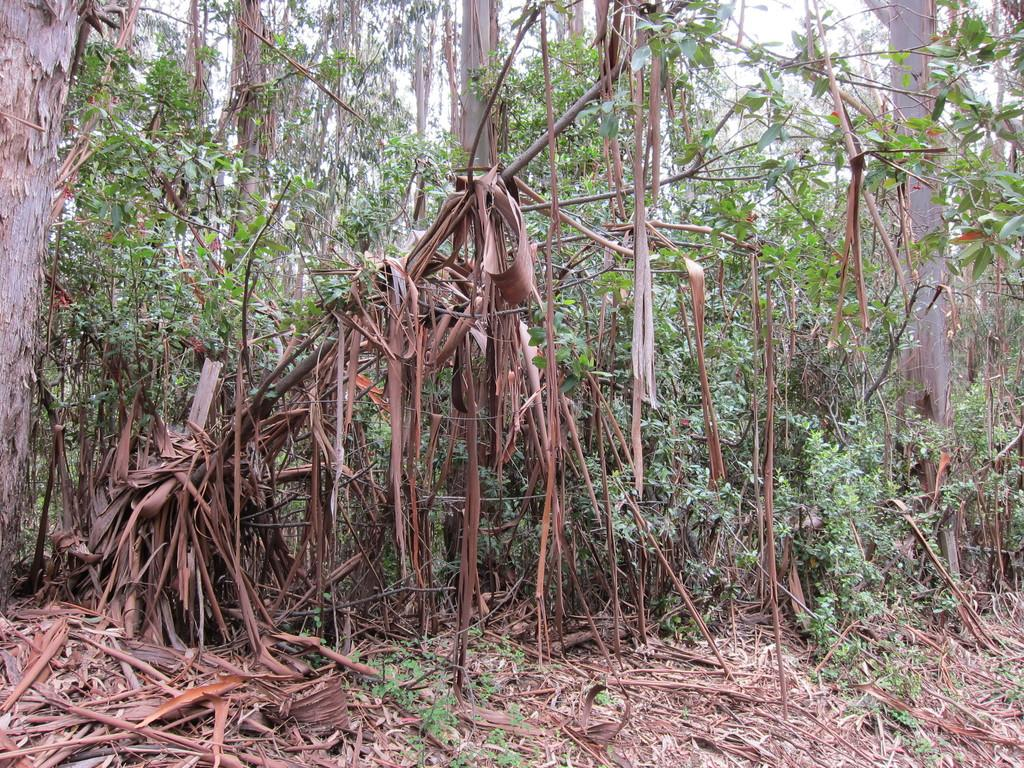What type of plants are in the image? There are dry plants in the image. What can be seen in the background of the image? There are trees in the background of the image. What type of hand can be seen holding the fog in the image? There is no hand or fog present in the image; it only features dry plants and trees in the background. 